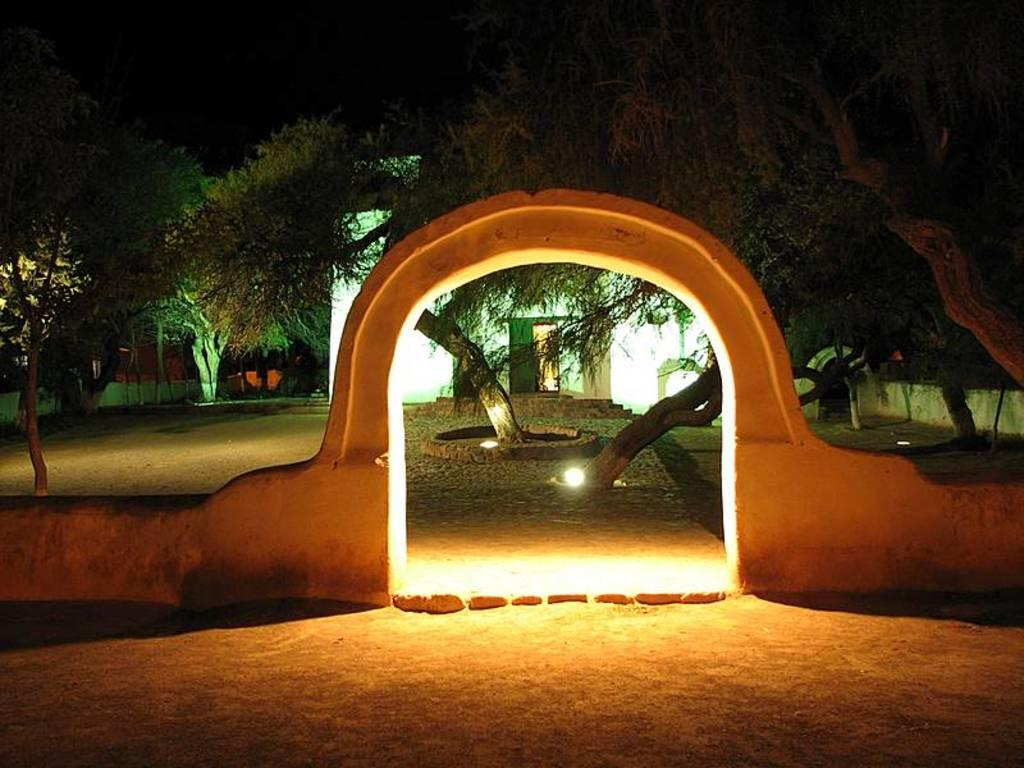What structure is located at the front of the image? There is an arch in the front of the image. What can be seen on the arch in the image? Light is visible on the arch. What type of vegetation is behind the arch? There are trees behind the arch. What type of building is visible behind the trees? There is a white-colored house behind the trees. How would you describe the overall lighting in the image? The background of the image is dark. Where is the tray of pears located in the image? There is no tray of pears present in the image. What type of fruit is being used to join the trees together in the image? There is no fruit or attempt to join the trees together in the image. 